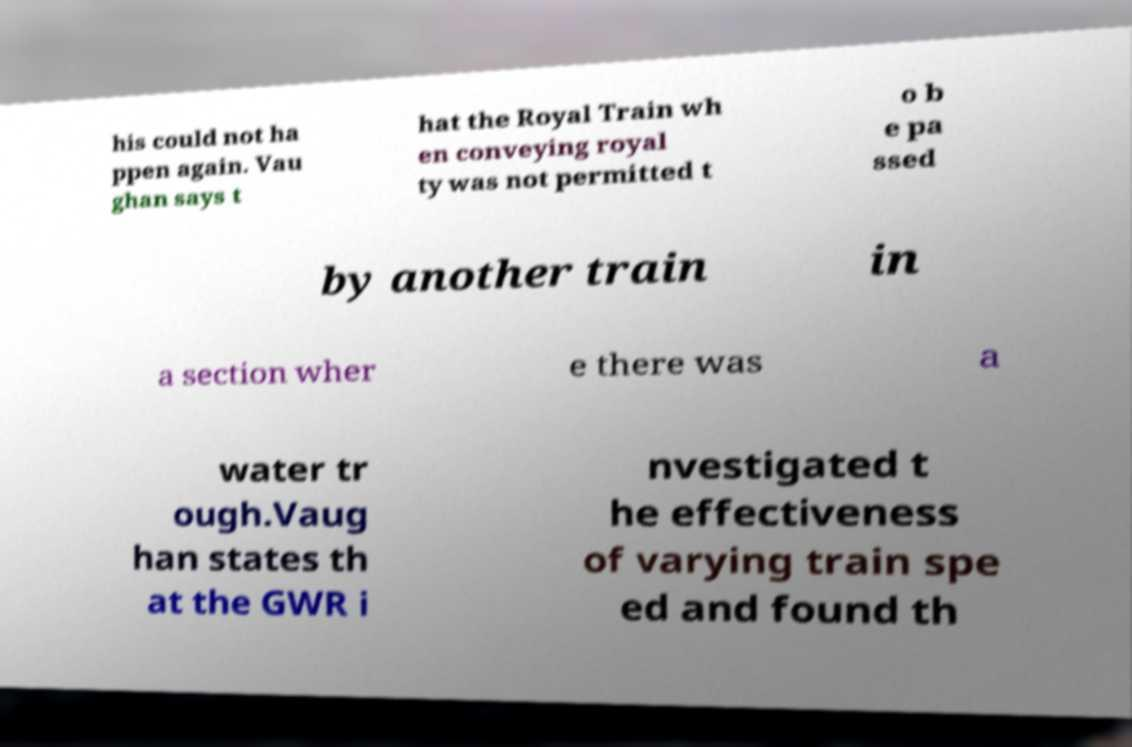Could you assist in decoding the text presented in this image and type it out clearly? his could not ha ppen again. Vau ghan says t hat the Royal Train wh en conveying royal ty was not permitted t o b e pa ssed by another train in a section wher e there was a water tr ough.Vaug han states th at the GWR i nvestigated t he effectiveness of varying train spe ed and found th 